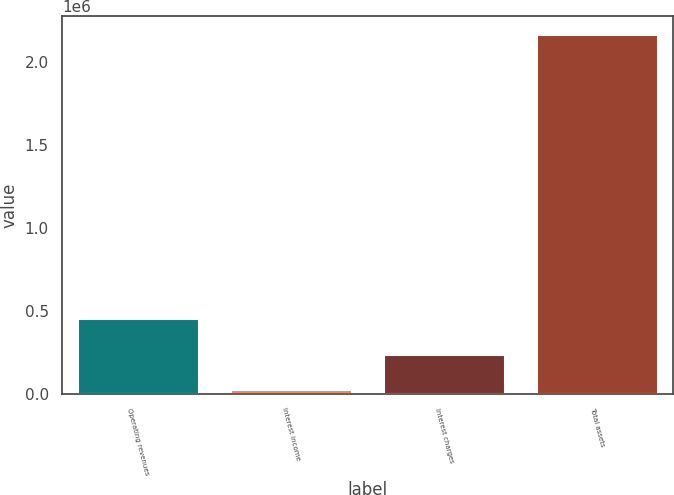<chart> <loc_0><loc_0><loc_500><loc_500><bar_chart><fcel>Operating revenues<fcel>Interest income<fcel>Interest charges<fcel>Total assets<nl><fcel>454406<fcel>26140<fcel>240273<fcel>2.16747e+06<nl></chart> 